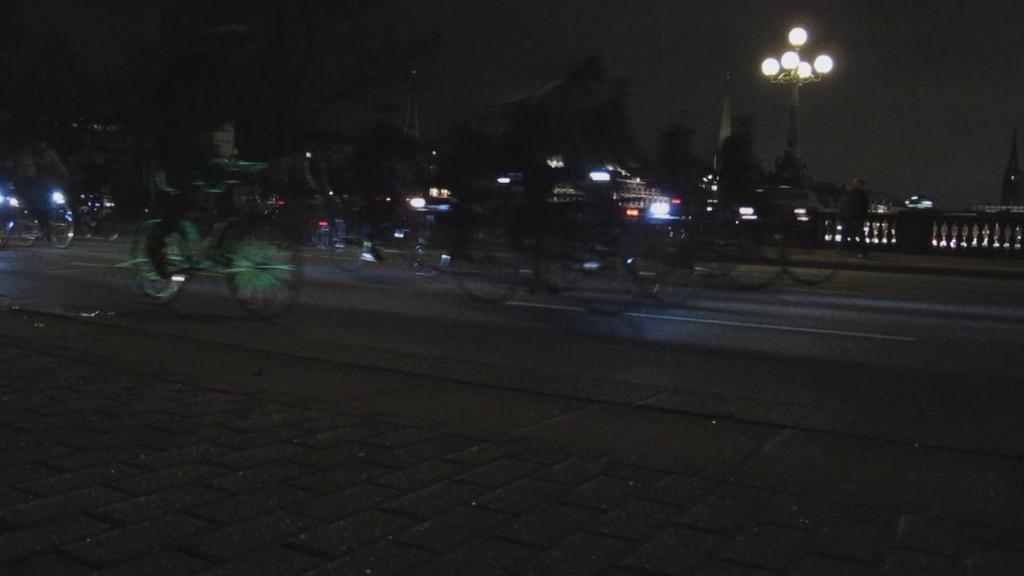In one or two sentences, can you explain what this image depicts? In the foreground of this image, there are people riding bicycles on the road. At the bottom, there is pavement. In the background, there is railing, lights, buildings and the dark sky. 